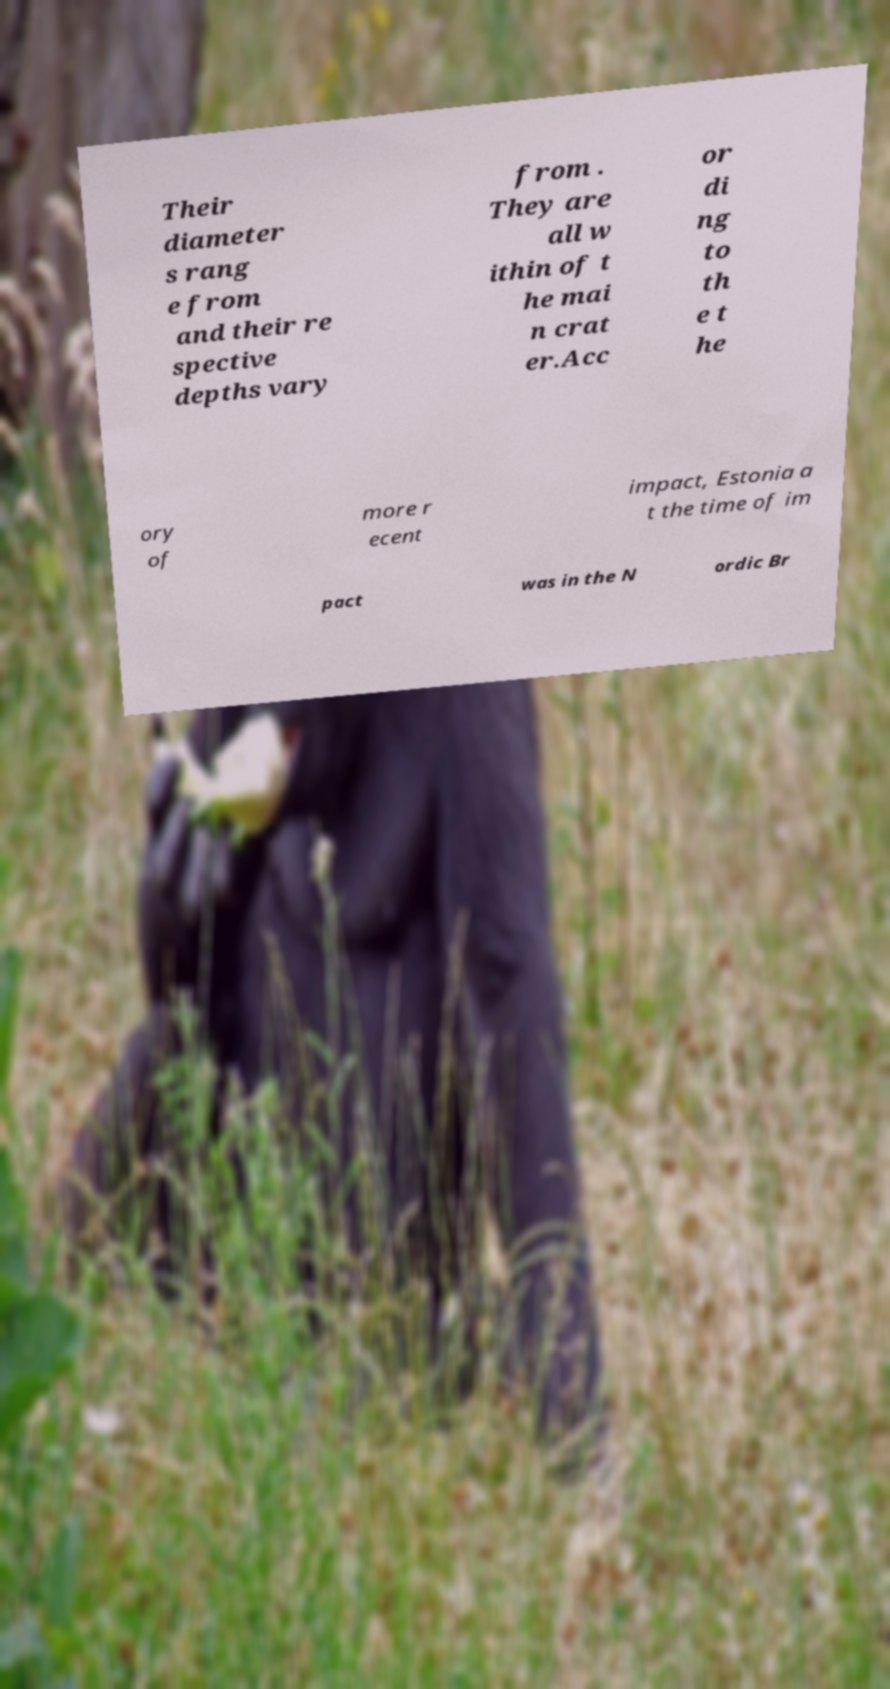Please identify and transcribe the text found in this image. Their diameter s rang e from and their re spective depths vary from . They are all w ithin of t he mai n crat er.Acc or di ng to th e t he ory of more r ecent impact, Estonia a t the time of im pact was in the N ordic Br 